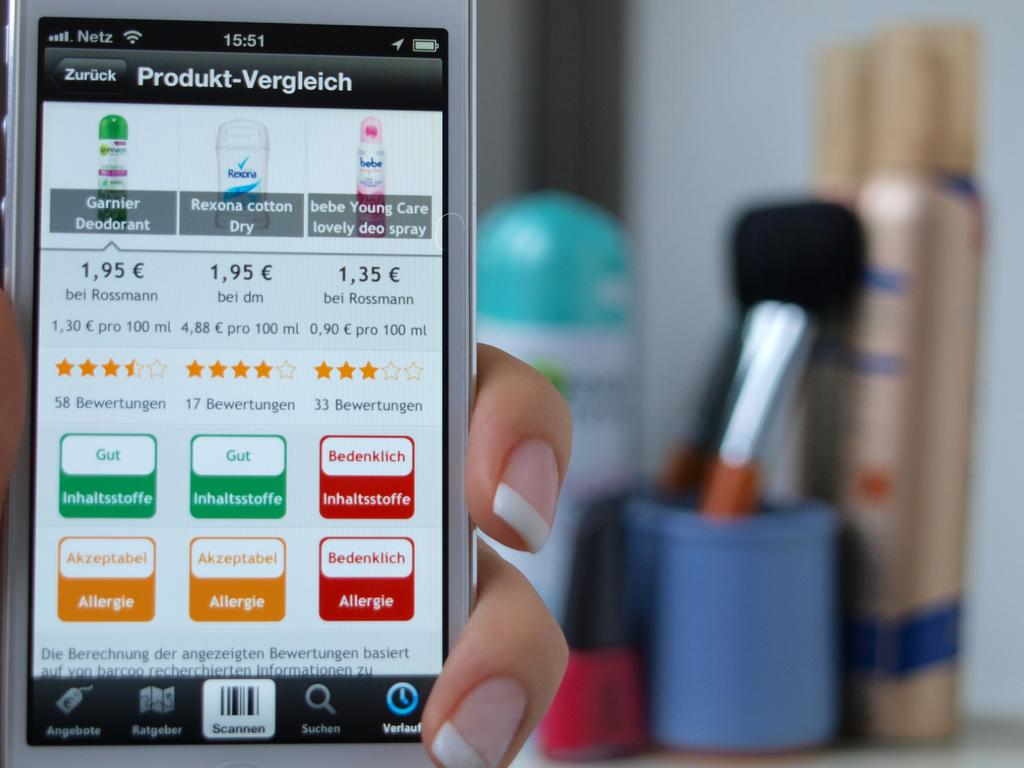<image>
Create a compact narrative representing the image presented. a phone that has the word produkt at the top of it 